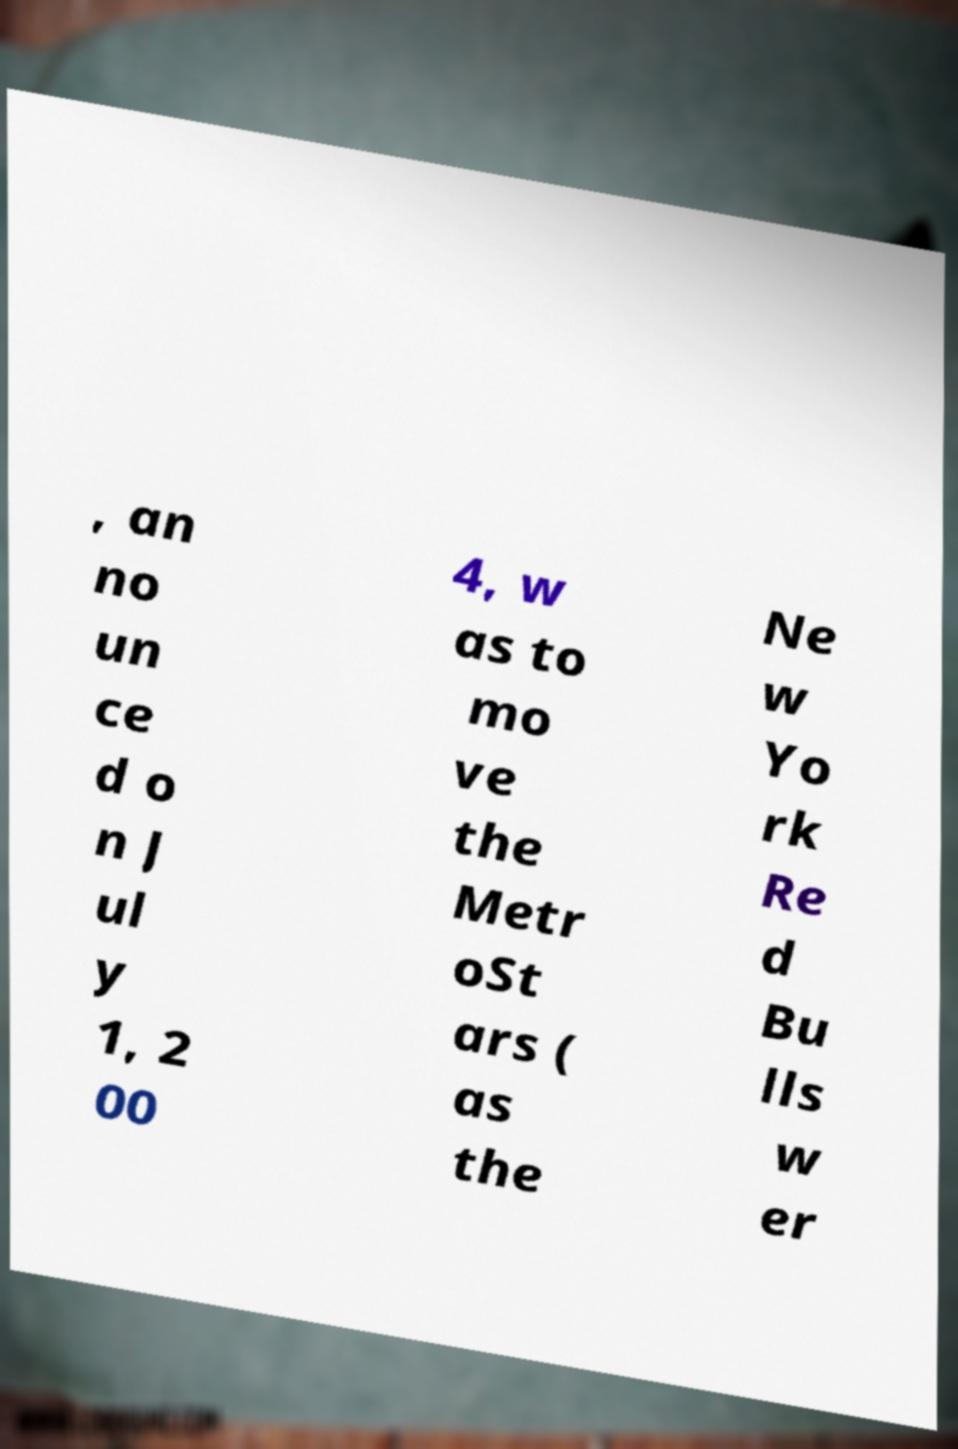For documentation purposes, I need the text within this image transcribed. Could you provide that? , an no un ce d o n J ul y 1, 2 00 4, w as to mo ve the Metr oSt ars ( as the Ne w Yo rk Re d Bu lls w er 